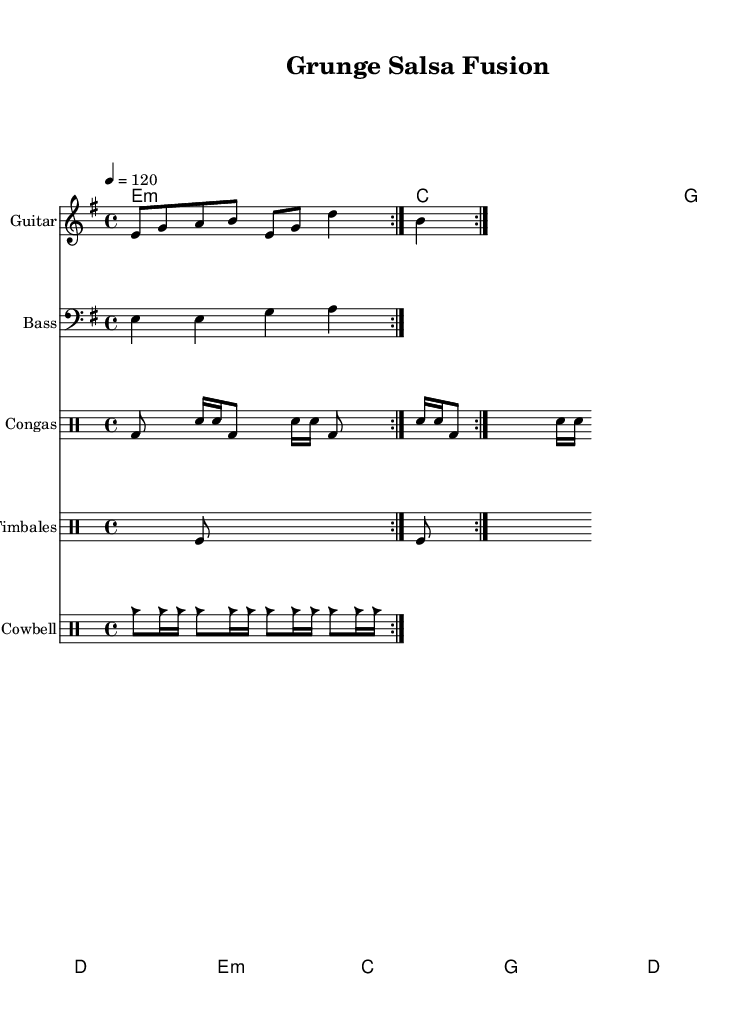What is the key signature of this music? The key signature is E minor, indicated by one sharp (F#).
Answer: E minor What is the time signature of this piece? The time signature is found at the beginning of the music and is indicated as 4/4.
Answer: 4/4 What is the tempo marking indicated in this sheet music? The tempo is indicated as quarter note equals 120, which means each quarter note should be played at a speed of 120 beats per minute.
Answer: 120 How many times is the guitar riff repeated? The guitar riff is repeated twice, as indicated by the repeat volta marks.
Answer: 2 What type of rhythm is primarily used in the congas pattern? The congas pattern primarily features a combination of bass drum and snare hits arranged in a syncopated rhythm typical of Latin music.
Answer: Syncopated Which chords are used in the chorus section? The chords in the chorus section include E minor, C major, G major, and D major, forming a traditional progression.
Answer: E minor, C major, G major, D major What is the overall genre fusion represented in this music? The music represents a fusion of Latin percussion elements and grunge-inspired guitar riffs, blending these distinct genres into a unique sound.
Answer: Latin and grunge 